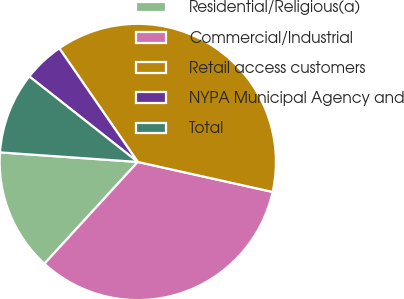Convert chart to OTSL. <chart><loc_0><loc_0><loc_500><loc_500><pie_chart><fcel>Residential/Religious(a)<fcel>Commercial/Industrial<fcel>Retail access customers<fcel>NYPA Municipal Agency and<fcel>Total<nl><fcel>14.29%<fcel>33.33%<fcel>38.1%<fcel>4.76%<fcel>9.52%<nl></chart> 